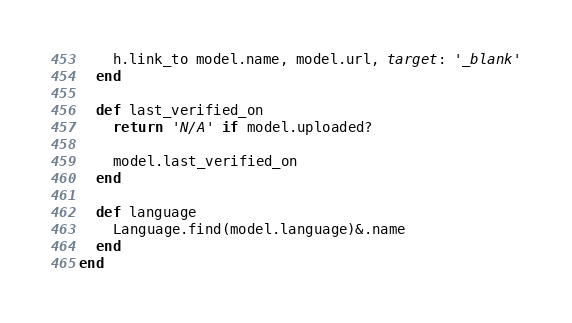Convert code to text. <code><loc_0><loc_0><loc_500><loc_500><_Ruby_>    h.link_to model.name, model.url, target: '_blank'
  end

  def last_verified_on
    return 'N/A' if model.uploaded?

    model.last_verified_on
  end

  def language
    Language.find(model.language)&.name
  end
end
</code> 